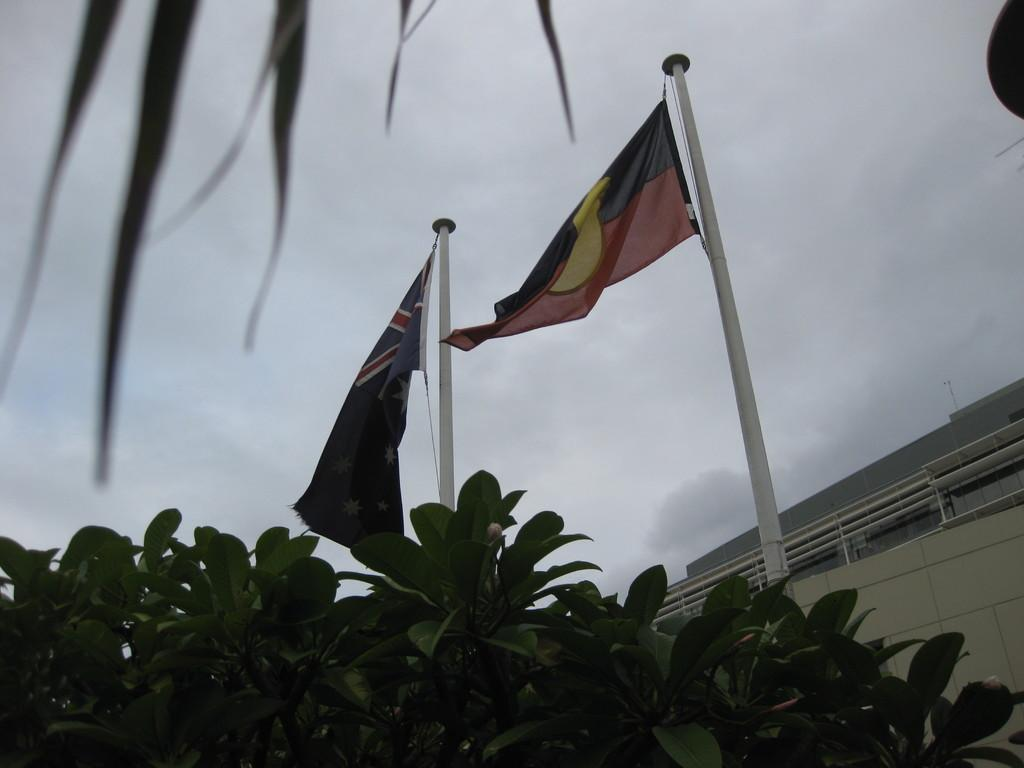What celestial bodies are present in the image? There are planets in the image. What national symbols are visible in the image? There are flags in the image. What are the flag poles used for in the image? There are flag posts in the image. What type of structures can be seen in the image? There are buildings in the image. What is visible in the sky in the image? The sky is visible in the image, and there are clouds in the sky. How many deer can be seen grazing in the image? There are no deer present in the image. What degree of temperature is being measured in the image? There is no temperature measurement device present in the image. 